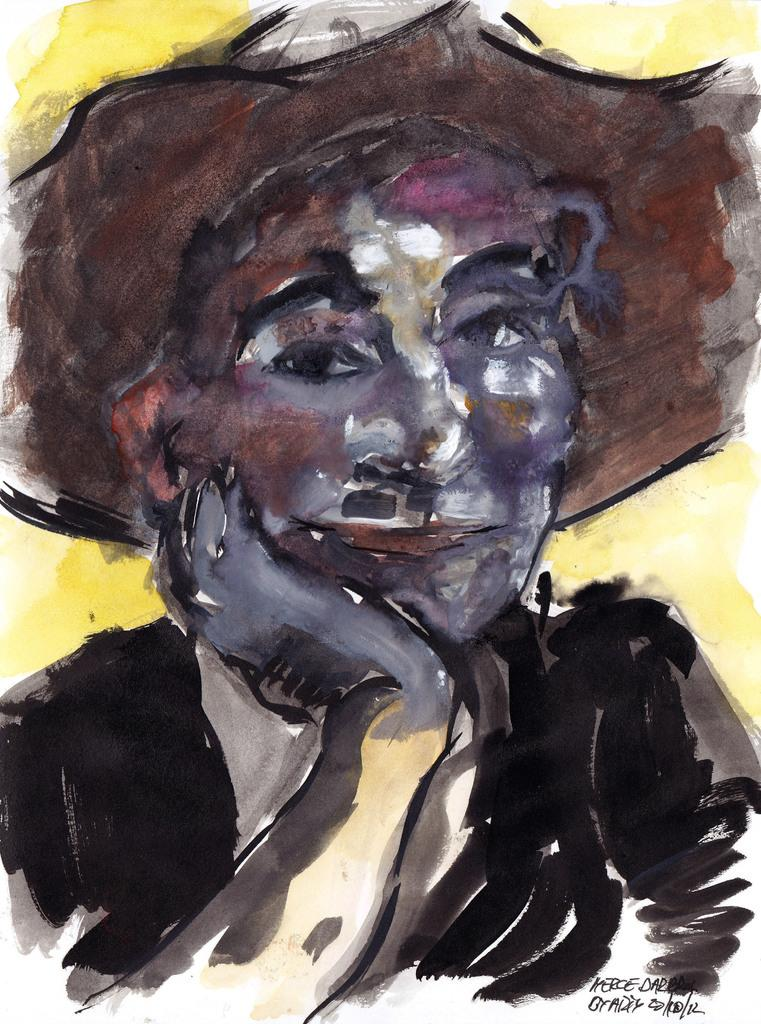What is the main subject of the image? There is a painting in the center of the image. What is depicted in the painting? The painting depicts a person wearing a hat. Is there any text present in the image? Yes, there is some text in the bottom right side of the image. How many members are on the team depicted in the alley in the image? There is no alley or team present in the image; it features a painting of a person wearing a hat and some text. 